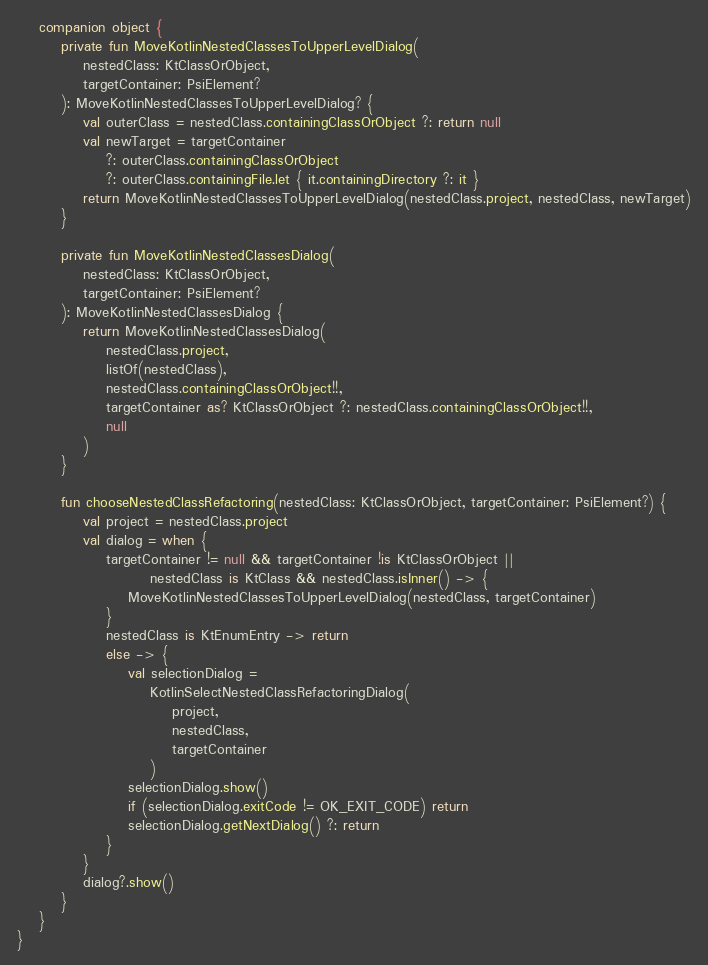Convert code to text. <code><loc_0><loc_0><loc_500><loc_500><_Kotlin_>    companion object {
        private fun MoveKotlinNestedClassesToUpperLevelDialog(
            nestedClass: KtClassOrObject,
            targetContainer: PsiElement?
        ): MoveKotlinNestedClassesToUpperLevelDialog? {
            val outerClass = nestedClass.containingClassOrObject ?: return null
            val newTarget = targetContainer
                ?: outerClass.containingClassOrObject
                ?: outerClass.containingFile.let { it.containingDirectory ?: it }
            return MoveKotlinNestedClassesToUpperLevelDialog(nestedClass.project, nestedClass, newTarget)
        }

        private fun MoveKotlinNestedClassesDialog(
            nestedClass: KtClassOrObject,
            targetContainer: PsiElement?
        ): MoveKotlinNestedClassesDialog {
            return MoveKotlinNestedClassesDialog(
                nestedClass.project,
                listOf(nestedClass),
                nestedClass.containingClassOrObject!!,
                targetContainer as? KtClassOrObject ?: nestedClass.containingClassOrObject!!,
                null
            )
        }

        fun chooseNestedClassRefactoring(nestedClass: KtClassOrObject, targetContainer: PsiElement?) {
            val project = nestedClass.project
            val dialog = when {
                targetContainer != null && targetContainer !is KtClassOrObject ||
                        nestedClass is KtClass && nestedClass.isInner() -> {
                    MoveKotlinNestedClassesToUpperLevelDialog(nestedClass, targetContainer)
                }
                nestedClass is KtEnumEntry -> return
                else -> {
                    val selectionDialog =
                        KotlinSelectNestedClassRefactoringDialog(
                            project,
                            nestedClass,
                            targetContainer
                        )
                    selectionDialog.show()
                    if (selectionDialog.exitCode != OK_EXIT_CODE) return
                    selectionDialog.getNextDialog() ?: return
                }
            }
            dialog?.show()
        }
    }
}</code> 